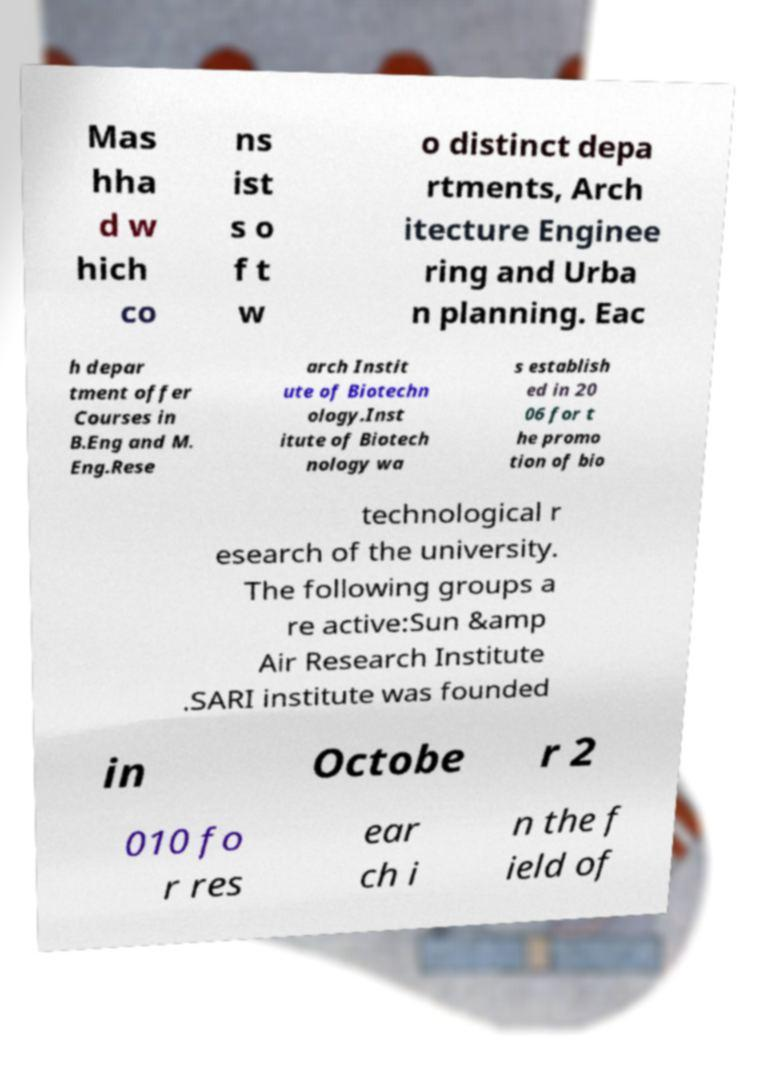Can you read and provide the text displayed in the image?This photo seems to have some interesting text. Can you extract and type it out for me? Mas hha d w hich co ns ist s o f t w o distinct depa rtments, Arch itecture Enginee ring and Urba n planning. Eac h depar tment offer Courses in B.Eng and M. Eng.Rese arch Instit ute of Biotechn ology.Inst itute of Biotech nology wa s establish ed in 20 06 for t he promo tion of bio technological r esearch of the university. The following groups a re active:Sun &amp Air Research Institute .SARI institute was founded in Octobe r 2 010 fo r res ear ch i n the f ield of 